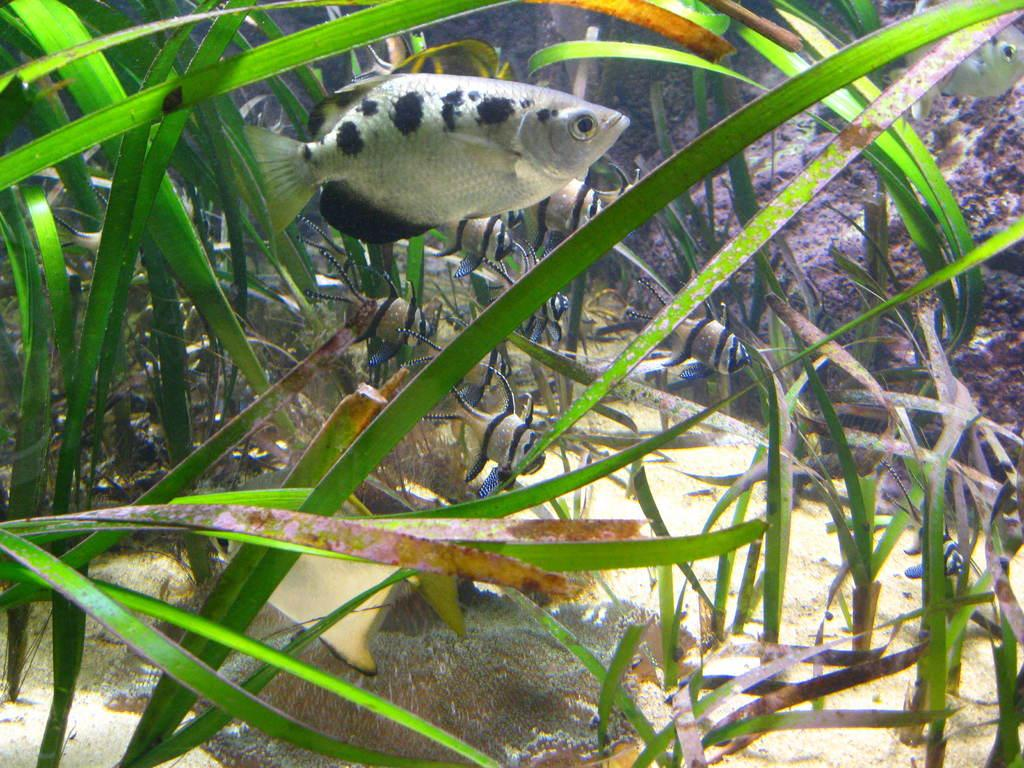What type of animals can be seen in the image? There are fish in the image. What else is present in the image besides the fish? There are plants in the image. What is the opinion of the insect about the park in the image? There is no insect or park present in the image, so it is not possible to determine an opinion about a park. 